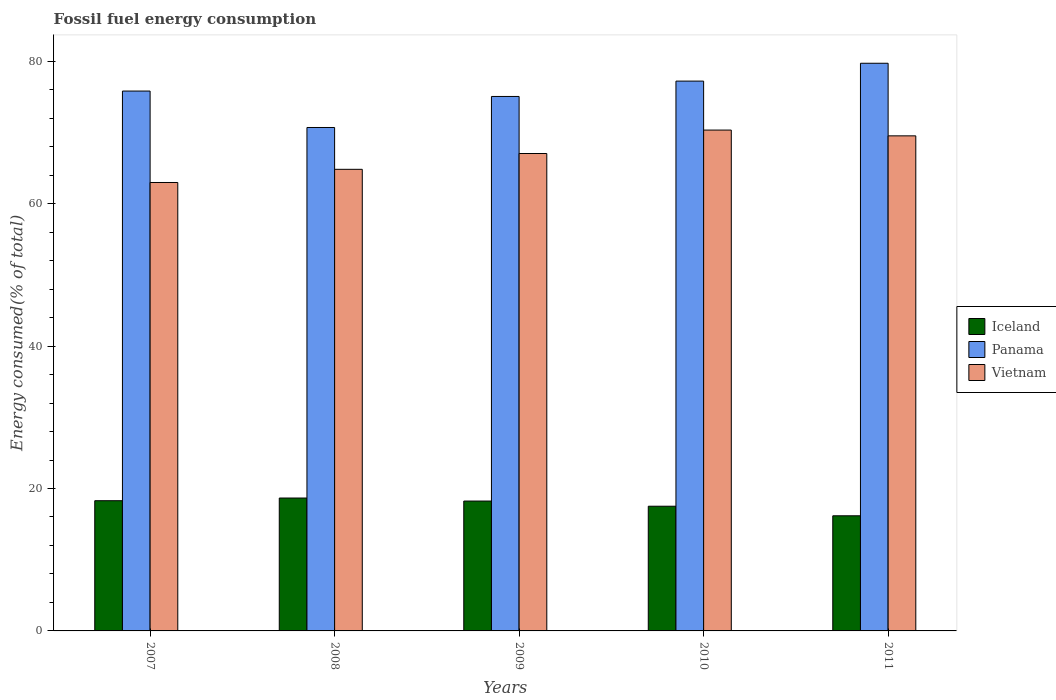How many different coloured bars are there?
Your response must be concise. 3. Are the number of bars on each tick of the X-axis equal?
Your answer should be compact. Yes. What is the label of the 5th group of bars from the left?
Provide a succinct answer. 2011. What is the percentage of energy consumed in Panama in 2007?
Offer a terse response. 75.81. Across all years, what is the maximum percentage of energy consumed in Panama?
Make the answer very short. 79.71. Across all years, what is the minimum percentage of energy consumed in Panama?
Offer a terse response. 70.69. In which year was the percentage of energy consumed in Vietnam maximum?
Offer a terse response. 2010. What is the total percentage of energy consumed in Vietnam in the graph?
Your answer should be very brief. 334.67. What is the difference between the percentage of energy consumed in Iceland in 2009 and that in 2011?
Offer a terse response. 2.07. What is the difference between the percentage of energy consumed in Vietnam in 2010 and the percentage of energy consumed in Panama in 2009?
Your answer should be compact. -4.72. What is the average percentage of energy consumed in Vietnam per year?
Offer a very short reply. 66.93. In the year 2010, what is the difference between the percentage of energy consumed in Panama and percentage of energy consumed in Vietnam?
Ensure brevity in your answer.  6.88. In how many years, is the percentage of energy consumed in Vietnam greater than 48 %?
Keep it short and to the point. 5. What is the ratio of the percentage of energy consumed in Iceland in 2009 to that in 2011?
Ensure brevity in your answer.  1.13. Is the difference between the percentage of energy consumed in Panama in 2007 and 2010 greater than the difference between the percentage of energy consumed in Vietnam in 2007 and 2010?
Your answer should be very brief. Yes. What is the difference between the highest and the second highest percentage of energy consumed in Vietnam?
Keep it short and to the point. 0.81. What is the difference between the highest and the lowest percentage of energy consumed in Panama?
Your answer should be very brief. 9.02. What does the 1st bar from the right in 2009 represents?
Your answer should be very brief. Vietnam. How many bars are there?
Give a very brief answer. 15. Are all the bars in the graph horizontal?
Offer a very short reply. No. What is the difference between two consecutive major ticks on the Y-axis?
Your answer should be very brief. 20. Does the graph contain any zero values?
Provide a succinct answer. No. Does the graph contain grids?
Ensure brevity in your answer.  No. Where does the legend appear in the graph?
Offer a terse response. Center right. What is the title of the graph?
Offer a terse response. Fossil fuel energy consumption. What is the label or title of the Y-axis?
Your response must be concise. Energy consumed(% of total). What is the Energy consumed(% of total) of Iceland in 2007?
Offer a terse response. 18.28. What is the Energy consumed(% of total) of Panama in 2007?
Your answer should be compact. 75.81. What is the Energy consumed(% of total) of Vietnam in 2007?
Make the answer very short. 62.97. What is the Energy consumed(% of total) in Iceland in 2008?
Offer a very short reply. 18.66. What is the Energy consumed(% of total) of Panama in 2008?
Give a very brief answer. 70.69. What is the Energy consumed(% of total) in Vietnam in 2008?
Offer a very short reply. 64.82. What is the Energy consumed(% of total) in Iceland in 2009?
Your response must be concise. 18.24. What is the Energy consumed(% of total) of Panama in 2009?
Give a very brief answer. 75.05. What is the Energy consumed(% of total) in Vietnam in 2009?
Ensure brevity in your answer.  67.04. What is the Energy consumed(% of total) of Iceland in 2010?
Provide a succinct answer. 17.51. What is the Energy consumed(% of total) in Panama in 2010?
Offer a very short reply. 77.2. What is the Energy consumed(% of total) of Vietnam in 2010?
Offer a terse response. 70.33. What is the Energy consumed(% of total) in Iceland in 2011?
Ensure brevity in your answer.  16.17. What is the Energy consumed(% of total) of Panama in 2011?
Give a very brief answer. 79.71. What is the Energy consumed(% of total) of Vietnam in 2011?
Ensure brevity in your answer.  69.52. Across all years, what is the maximum Energy consumed(% of total) in Iceland?
Your response must be concise. 18.66. Across all years, what is the maximum Energy consumed(% of total) of Panama?
Offer a very short reply. 79.71. Across all years, what is the maximum Energy consumed(% of total) in Vietnam?
Offer a very short reply. 70.33. Across all years, what is the minimum Energy consumed(% of total) of Iceland?
Offer a terse response. 16.17. Across all years, what is the minimum Energy consumed(% of total) in Panama?
Offer a very short reply. 70.69. Across all years, what is the minimum Energy consumed(% of total) of Vietnam?
Your answer should be compact. 62.97. What is the total Energy consumed(% of total) of Iceland in the graph?
Your answer should be very brief. 88.86. What is the total Energy consumed(% of total) in Panama in the graph?
Your response must be concise. 378.46. What is the total Energy consumed(% of total) of Vietnam in the graph?
Give a very brief answer. 334.67. What is the difference between the Energy consumed(% of total) in Iceland in 2007 and that in 2008?
Give a very brief answer. -0.38. What is the difference between the Energy consumed(% of total) in Panama in 2007 and that in 2008?
Your answer should be very brief. 5.12. What is the difference between the Energy consumed(% of total) in Vietnam in 2007 and that in 2008?
Your answer should be very brief. -1.85. What is the difference between the Energy consumed(% of total) in Iceland in 2007 and that in 2009?
Offer a terse response. 0.05. What is the difference between the Energy consumed(% of total) of Panama in 2007 and that in 2009?
Your answer should be compact. 0.76. What is the difference between the Energy consumed(% of total) of Vietnam in 2007 and that in 2009?
Make the answer very short. -4.07. What is the difference between the Energy consumed(% of total) of Iceland in 2007 and that in 2010?
Provide a short and direct response. 0.77. What is the difference between the Energy consumed(% of total) in Panama in 2007 and that in 2010?
Keep it short and to the point. -1.4. What is the difference between the Energy consumed(% of total) in Vietnam in 2007 and that in 2010?
Make the answer very short. -7.36. What is the difference between the Energy consumed(% of total) of Iceland in 2007 and that in 2011?
Provide a succinct answer. 2.12. What is the difference between the Energy consumed(% of total) in Panama in 2007 and that in 2011?
Make the answer very short. -3.9. What is the difference between the Energy consumed(% of total) of Vietnam in 2007 and that in 2011?
Keep it short and to the point. -6.55. What is the difference between the Energy consumed(% of total) in Iceland in 2008 and that in 2009?
Provide a succinct answer. 0.42. What is the difference between the Energy consumed(% of total) in Panama in 2008 and that in 2009?
Provide a succinct answer. -4.36. What is the difference between the Energy consumed(% of total) of Vietnam in 2008 and that in 2009?
Offer a terse response. -2.22. What is the difference between the Energy consumed(% of total) in Iceland in 2008 and that in 2010?
Keep it short and to the point. 1.15. What is the difference between the Energy consumed(% of total) of Panama in 2008 and that in 2010?
Provide a short and direct response. -6.51. What is the difference between the Energy consumed(% of total) in Vietnam in 2008 and that in 2010?
Offer a very short reply. -5.51. What is the difference between the Energy consumed(% of total) in Iceland in 2008 and that in 2011?
Make the answer very short. 2.49. What is the difference between the Energy consumed(% of total) in Panama in 2008 and that in 2011?
Your answer should be very brief. -9.02. What is the difference between the Energy consumed(% of total) in Vietnam in 2008 and that in 2011?
Offer a terse response. -4.7. What is the difference between the Energy consumed(% of total) in Iceland in 2009 and that in 2010?
Ensure brevity in your answer.  0.73. What is the difference between the Energy consumed(% of total) of Panama in 2009 and that in 2010?
Your response must be concise. -2.16. What is the difference between the Energy consumed(% of total) of Vietnam in 2009 and that in 2010?
Provide a short and direct response. -3.29. What is the difference between the Energy consumed(% of total) of Iceland in 2009 and that in 2011?
Give a very brief answer. 2.07. What is the difference between the Energy consumed(% of total) in Panama in 2009 and that in 2011?
Offer a very short reply. -4.66. What is the difference between the Energy consumed(% of total) in Vietnam in 2009 and that in 2011?
Give a very brief answer. -2.48. What is the difference between the Energy consumed(% of total) in Iceland in 2010 and that in 2011?
Offer a terse response. 1.34. What is the difference between the Energy consumed(% of total) of Panama in 2010 and that in 2011?
Provide a short and direct response. -2.51. What is the difference between the Energy consumed(% of total) of Vietnam in 2010 and that in 2011?
Provide a short and direct response. 0.81. What is the difference between the Energy consumed(% of total) in Iceland in 2007 and the Energy consumed(% of total) in Panama in 2008?
Your answer should be very brief. -52.41. What is the difference between the Energy consumed(% of total) of Iceland in 2007 and the Energy consumed(% of total) of Vietnam in 2008?
Make the answer very short. -46.53. What is the difference between the Energy consumed(% of total) in Panama in 2007 and the Energy consumed(% of total) in Vietnam in 2008?
Offer a very short reply. 10.99. What is the difference between the Energy consumed(% of total) in Iceland in 2007 and the Energy consumed(% of total) in Panama in 2009?
Give a very brief answer. -56.76. What is the difference between the Energy consumed(% of total) in Iceland in 2007 and the Energy consumed(% of total) in Vietnam in 2009?
Offer a very short reply. -48.75. What is the difference between the Energy consumed(% of total) of Panama in 2007 and the Energy consumed(% of total) of Vietnam in 2009?
Your response must be concise. 8.77. What is the difference between the Energy consumed(% of total) of Iceland in 2007 and the Energy consumed(% of total) of Panama in 2010?
Provide a succinct answer. -58.92. What is the difference between the Energy consumed(% of total) in Iceland in 2007 and the Energy consumed(% of total) in Vietnam in 2010?
Make the answer very short. -52.04. What is the difference between the Energy consumed(% of total) of Panama in 2007 and the Energy consumed(% of total) of Vietnam in 2010?
Your response must be concise. 5.48. What is the difference between the Energy consumed(% of total) in Iceland in 2007 and the Energy consumed(% of total) in Panama in 2011?
Offer a terse response. -61.43. What is the difference between the Energy consumed(% of total) of Iceland in 2007 and the Energy consumed(% of total) of Vietnam in 2011?
Your answer should be very brief. -51.23. What is the difference between the Energy consumed(% of total) of Panama in 2007 and the Energy consumed(% of total) of Vietnam in 2011?
Offer a very short reply. 6.29. What is the difference between the Energy consumed(% of total) in Iceland in 2008 and the Energy consumed(% of total) in Panama in 2009?
Your answer should be very brief. -56.39. What is the difference between the Energy consumed(% of total) of Iceland in 2008 and the Energy consumed(% of total) of Vietnam in 2009?
Ensure brevity in your answer.  -48.38. What is the difference between the Energy consumed(% of total) of Panama in 2008 and the Energy consumed(% of total) of Vietnam in 2009?
Keep it short and to the point. 3.65. What is the difference between the Energy consumed(% of total) in Iceland in 2008 and the Energy consumed(% of total) in Panama in 2010?
Your answer should be very brief. -58.54. What is the difference between the Energy consumed(% of total) in Iceland in 2008 and the Energy consumed(% of total) in Vietnam in 2010?
Ensure brevity in your answer.  -51.67. What is the difference between the Energy consumed(% of total) in Panama in 2008 and the Energy consumed(% of total) in Vietnam in 2010?
Your answer should be compact. 0.36. What is the difference between the Energy consumed(% of total) in Iceland in 2008 and the Energy consumed(% of total) in Panama in 2011?
Provide a short and direct response. -61.05. What is the difference between the Energy consumed(% of total) in Iceland in 2008 and the Energy consumed(% of total) in Vietnam in 2011?
Your answer should be compact. -50.86. What is the difference between the Energy consumed(% of total) of Panama in 2008 and the Energy consumed(% of total) of Vietnam in 2011?
Keep it short and to the point. 1.17. What is the difference between the Energy consumed(% of total) in Iceland in 2009 and the Energy consumed(% of total) in Panama in 2010?
Make the answer very short. -58.97. What is the difference between the Energy consumed(% of total) of Iceland in 2009 and the Energy consumed(% of total) of Vietnam in 2010?
Keep it short and to the point. -52.09. What is the difference between the Energy consumed(% of total) of Panama in 2009 and the Energy consumed(% of total) of Vietnam in 2010?
Provide a succinct answer. 4.72. What is the difference between the Energy consumed(% of total) of Iceland in 2009 and the Energy consumed(% of total) of Panama in 2011?
Keep it short and to the point. -61.47. What is the difference between the Energy consumed(% of total) in Iceland in 2009 and the Energy consumed(% of total) in Vietnam in 2011?
Your answer should be very brief. -51.28. What is the difference between the Energy consumed(% of total) in Panama in 2009 and the Energy consumed(% of total) in Vietnam in 2011?
Your answer should be compact. 5.53. What is the difference between the Energy consumed(% of total) in Iceland in 2010 and the Energy consumed(% of total) in Panama in 2011?
Offer a very short reply. -62.2. What is the difference between the Energy consumed(% of total) in Iceland in 2010 and the Energy consumed(% of total) in Vietnam in 2011?
Keep it short and to the point. -52.01. What is the difference between the Energy consumed(% of total) of Panama in 2010 and the Energy consumed(% of total) of Vietnam in 2011?
Offer a very short reply. 7.69. What is the average Energy consumed(% of total) in Iceland per year?
Ensure brevity in your answer.  17.77. What is the average Energy consumed(% of total) of Panama per year?
Offer a terse response. 75.69. What is the average Energy consumed(% of total) of Vietnam per year?
Offer a very short reply. 66.93. In the year 2007, what is the difference between the Energy consumed(% of total) of Iceland and Energy consumed(% of total) of Panama?
Offer a terse response. -57.52. In the year 2007, what is the difference between the Energy consumed(% of total) in Iceland and Energy consumed(% of total) in Vietnam?
Ensure brevity in your answer.  -44.68. In the year 2007, what is the difference between the Energy consumed(% of total) of Panama and Energy consumed(% of total) of Vietnam?
Provide a short and direct response. 12.84. In the year 2008, what is the difference between the Energy consumed(% of total) of Iceland and Energy consumed(% of total) of Panama?
Keep it short and to the point. -52.03. In the year 2008, what is the difference between the Energy consumed(% of total) in Iceland and Energy consumed(% of total) in Vietnam?
Your response must be concise. -46.16. In the year 2008, what is the difference between the Energy consumed(% of total) in Panama and Energy consumed(% of total) in Vietnam?
Your answer should be compact. 5.87. In the year 2009, what is the difference between the Energy consumed(% of total) of Iceland and Energy consumed(% of total) of Panama?
Your answer should be compact. -56.81. In the year 2009, what is the difference between the Energy consumed(% of total) in Iceland and Energy consumed(% of total) in Vietnam?
Provide a short and direct response. -48.8. In the year 2009, what is the difference between the Energy consumed(% of total) of Panama and Energy consumed(% of total) of Vietnam?
Your answer should be compact. 8.01. In the year 2010, what is the difference between the Energy consumed(% of total) of Iceland and Energy consumed(% of total) of Panama?
Provide a short and direct response. -59.69. In the year 2010, what is the difference between the Energy consumed(% of total) in Iceland and Energy consumed(% of total) in Vietnam?
Keep it short and to the point. -52.82. In the year 2010, what is the difference between the Energy consumed(% of total) in Panama and Energy consumed(% of total) in Vietnam?
Give a very brief answer. 6.88. In the year 2011, what is the difference between the Energy consumed(% of total) in Iceland and Energy consumed(% of total) in Panama?
Your response must be concise. -63.54. In the year 2011, what is the difference between the Energy consumed(% of total) of Iceland and Energy consumed(% of total) of Vietnam?
Offer a terse response. -53.35. In the year 2011, what is the difference between the Energy consumed(% of total) in Panama and Energy consumed(% of total) in Vietnam?
Ensure brevity in your answer.  10.19. What is the ratio of the Energy consumed(% of total) of Iceland in 2007 to that in 2008?
Provide a succinct answer. 0.98. What is the ratio of the Energy consumed(% of total) in Panama in 2007 to that in 2008?
Give a very brief answer. 1.07. What is the ratio of the Energy consumed(% of total) of Vietnam in 2007 to that in 2008?
Keep it short and to the point. 0.97. What is the ratio of the Energy consumed(% of total) in Vietnam in 2007 to that in 2009?
Keep it short and to the point. 0.94. What is the ratio of the Energy consumed(% of total) in Iceland in 2007 to that in 2010?
Ensure brevity in your answer.  1.04. What is the ratio of the Energy consumed(% of total) of Panama in 2007 to that in 2010?
Keep it short and to the point. 0.98. What is the ratio of the Energy consumed(% of total) in Vietnam in 2007 to that in 2010?
Keep it short and to the point. 0.9. What is the ratio of the Energy consumed(% of total) of Iceland in 2007 to that in 2011?
Your answer should be very brief. 1.13. What is the ratio of the Energy consumed(% of total) in Panama in 2007 to that in 2011?
Your response must be concise. 0.95. What is the ratio of the Energy consumed(% of total) of Vietnam in 2007 to that in 2011?
Offer a very short reply. 0.91. What is the ratio of the Energy consumed(% of total) in Iceland in 2008 to that in 2009?
Give a very brief answer. 1.02. What is the ratio of the Energy consumed(% of total) in Panama in 2008 to that in 2009?
Offer a terse response. 0.94. What is the ratio of the Energy consumed(% of total) of Vietnam in 2008 to that in 2009?
Give a very brief answer. 0.97. What is the ratio of the Energy consumed(% of total) of Iceland in 2008 to that in 2010?
Offer a terse response. 1.07. What is the ratio of the Energy consumed(% of total) in Panama in 2008 to that in 2010?
Offer a terse response. 0.92. What is the ratio of the Energy consumed(% of total) in Vietnam in 2008 to that in 2010?
Make the answer very short. 0.92. What is the ratio of the Energy consumed(% of total) in Iceland in 2008 to that in 2011?
Your response must be concise. 1.15. What is the ratio of the Energy consumed(% of total) in Panama in 2008 to that in 2011?
Offer a terse response. 0.89. What is the ratio of the Energy consumed(% of total) in Vietnam in 2008 to that in 2011?
Offer a terse response. 0.93. What is the ratio of the Energy consumed(% of total) of Iceland in 2009 to that in 2010?
Your response must be concise. 1.04. What is the ratio of the Energy consumed(% of total) in Panama in 2009 to that in 2010?
Give a very brief answer. 0.97. What is the ratio of the Energy consumed(% of total) in Vietnam in 2009 to that in 2010?
Your answer should be compact. 0.95. What is the ratio of the Energy consumed(% of total) of Iceland in 2009 to that in 2011?
Make the answer very short. 1.13. What is the ratio of the Energy consumed(% of total) in Panama in 2009 to that in 2011?
Your answer should be very brief. 0.94. What is the ratio of the Energy consumed(% of total) of Iceland in 2010 to that in 2011?
Make the answer very short. 1.08. What is the ratio of the Energy consumed(% of total) of Panama in 2010 to that in 2011?
Your response must be concise. 0.97. What is the ratio of the Energy consumed(% of total) in Vietnam in 2010 to that in 2011?
Provide a short and direct response. 1.01. What is the difference between the highest and the second highest Energy consumed(% of total) in Iceland?
Your answer should be compact. 0.38. What is the difference between the highest and the second highest Energy consumed(% of total) in Panama?
Your answer should be compact. 2.51. What is the difference between the highest and the second highest Energy consumed(% of total) of Vietnam?
Provide a succinct answer. 0.81. What is the difference between the highest and the lowest Energy consumed(% of total) in Iceland?
Make the answer very short. 2.49. What is the difference between the highest and the lowest Energy consumed(% of total) of Panama?
Ensure brevity in your answer.  9.02. What is the difference between the highest and the lowest Energy consumed(% of total) in Vietnam?
Ensure brevity in your answer.  7.36. 